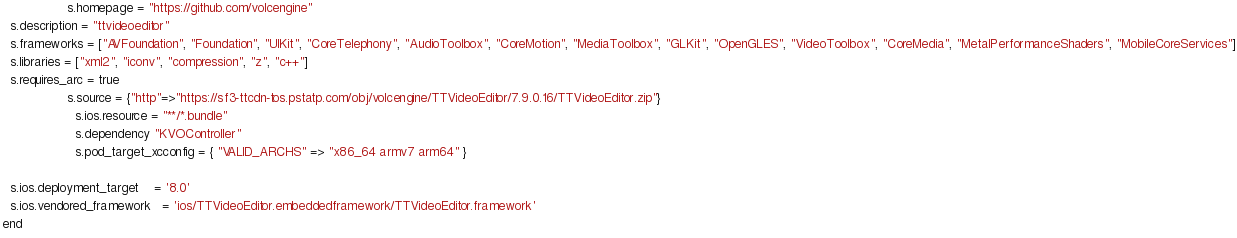Convert code to text. <code><loc_0><loc_0><loc_500><loc_500><_Ruby_>                 s.homepage = "https://github.com/volcengine"
  s.description = "ttvideoeditor"
  s.frameworks = ["AVFoundation", "Foundation", "UIKit", "CoreTelephony", "AudioToolbox", "CoreMotion", "MediaToolbox", "GLKit", "OpenGLES", "VideoToolbox", "CoreMedia", "MetalPerformanceShaders", "MobileCoreServices"]
  s.libraries = ["xml2", "iconv", "compression", "z", "c++"]
  s.requires_arc = true
                 s.source = {"http"=>"https://sf3-ttcdn-tos.pstatp.com/obj/volcengine/TTVideoEditor/7.9.0.16/TTVideoEditor.zip"}
                   s.ios.resource = "**/*.bundle"
                   s.dependency "KVOController"
                   s.pod_target_xcconfig = { "VALID_ARCHS" => "x86_64 armv7 arm64" }

  s.ios.deployment_target    = '8.0'
  s.ios.vendored_framework   = 'ios/TTVideoEditor.embeddedframework/TTVideoEditor.framework'
end
</code> 